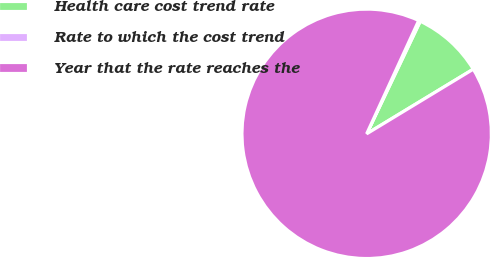Convert chart to OTSL. <chart><loc_0><loc_0><loc_500><loc_500><pie_chart><fcel>Health care cost trend rate<fcel>Rate to which the cost trend<fcel>Year that the rate reaches the<nl><fcel>9.25%<fcel>0.22%<fcel>90.52%<nl></chart> 